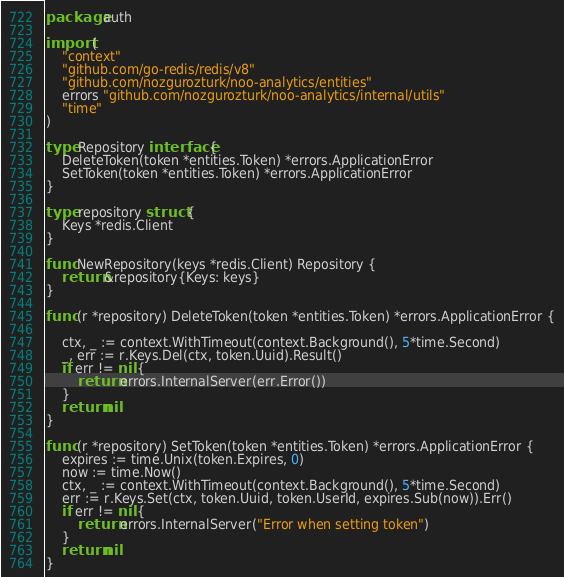<code> <loc_0><loc_0><loc_500><loc_500><_Go_>package auth

import (
	"context"
	"github.com/go-redis/redis/v8"
	"github.com/nozgurozturk/noo-analytics/entities"
	errors "github.com/nozgurozturk/noo-analytics/internal/utils"
	"time"
)

type Repository interface {
	DeleteToken(token *entities.Token) *errors.ApplicationError
	SetToken(token *entities.Token) *errors.ApplicationError
}

type repository struct {
	Keys *redis.Client
}

func NewRepository(keys *redis.Client) Repository {
	return &repository{Keys: keys}
}

func (r *repository) DeleteToken(token *entities.Token) *errors.ApplicationError {

	ctx, _ := context.WithTimeout(context.Background(), 5*time.Second)
	_, err := r.Keys.Del(ctx, token.Uuid).Result()
	if err != nil {
		return errors.InternalServer(err.Error())
	}
	return nil
}

func (r *repository) SetToken(token *entities.Token) *errors.ApplicationError {
	expires := time.Unix(token.Expires, 0)
	now := time.Now()
	ctx, _ := context.WithTimeout(context.Background(), 5*time.Second)
	err := r.Keys.Set(ctx, token.Uuid, token.UserId, expires.Sub(now)).Err()
	if err != nil {
		return errors.InternalServer("Error when setting token")
	}
	return nil
}
</code> 